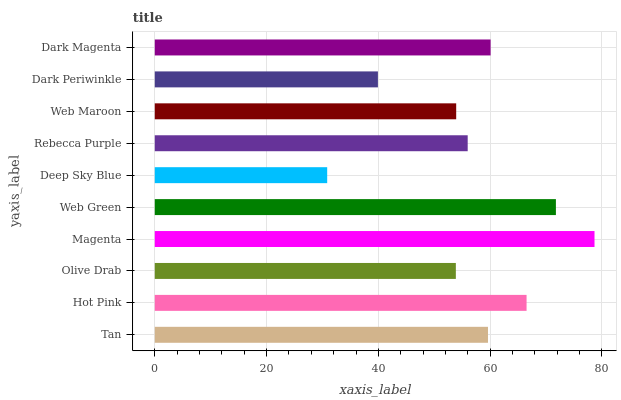Is Deep Sky Blue the minimum?
Answer yes or no. Yes. Is Magenta the maximum?
Answer yes or no. Yes. Is Hot Pink the minimum?
Answer yes or no. No. Is Hot Pink the maximum?
Answer yes or no. No. Is Hot Pink greater than Tan?
Answer yes or no. Yes. Is Tan less than Hot Pink?
Answer yes or no. Yes. Is Tan greater than Hot Pink?
Answer yes or no. No. Is Hot Pink less than Tan?
Answer yes or no. No. Is Tan the high median?
Answer yes or no. Yes. Is Rebecca Purple the low median?
Answer yes or no. Yes. Is Olive Drab the high median?
Answer yes or no. No. Is Magenta the low median?
Answer yes or no. No. 